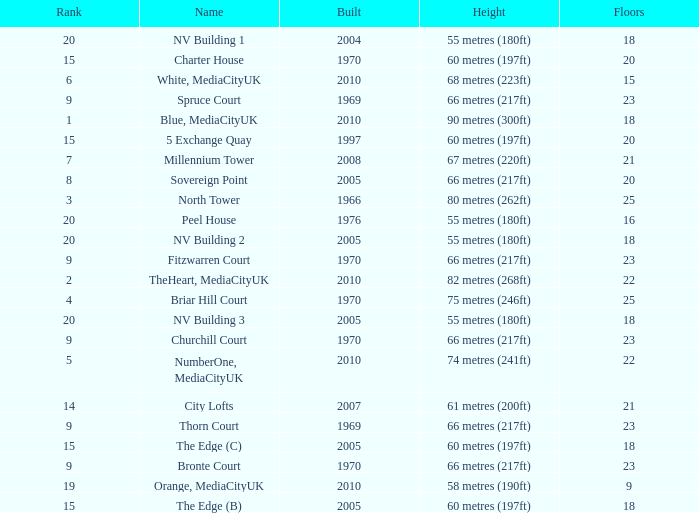What is the total number of Built, when Floors is less than 22, when Rank is less than 8, and when Name is White, Mediacityuk? 1.0. 